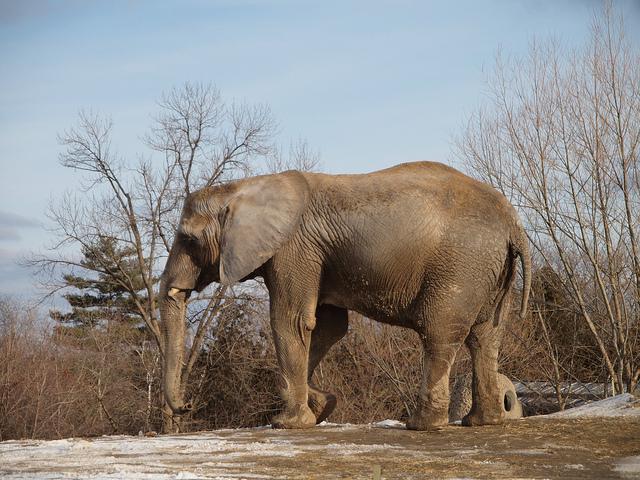How many birds are standing in the water?
Give a very brief answer. 0. 